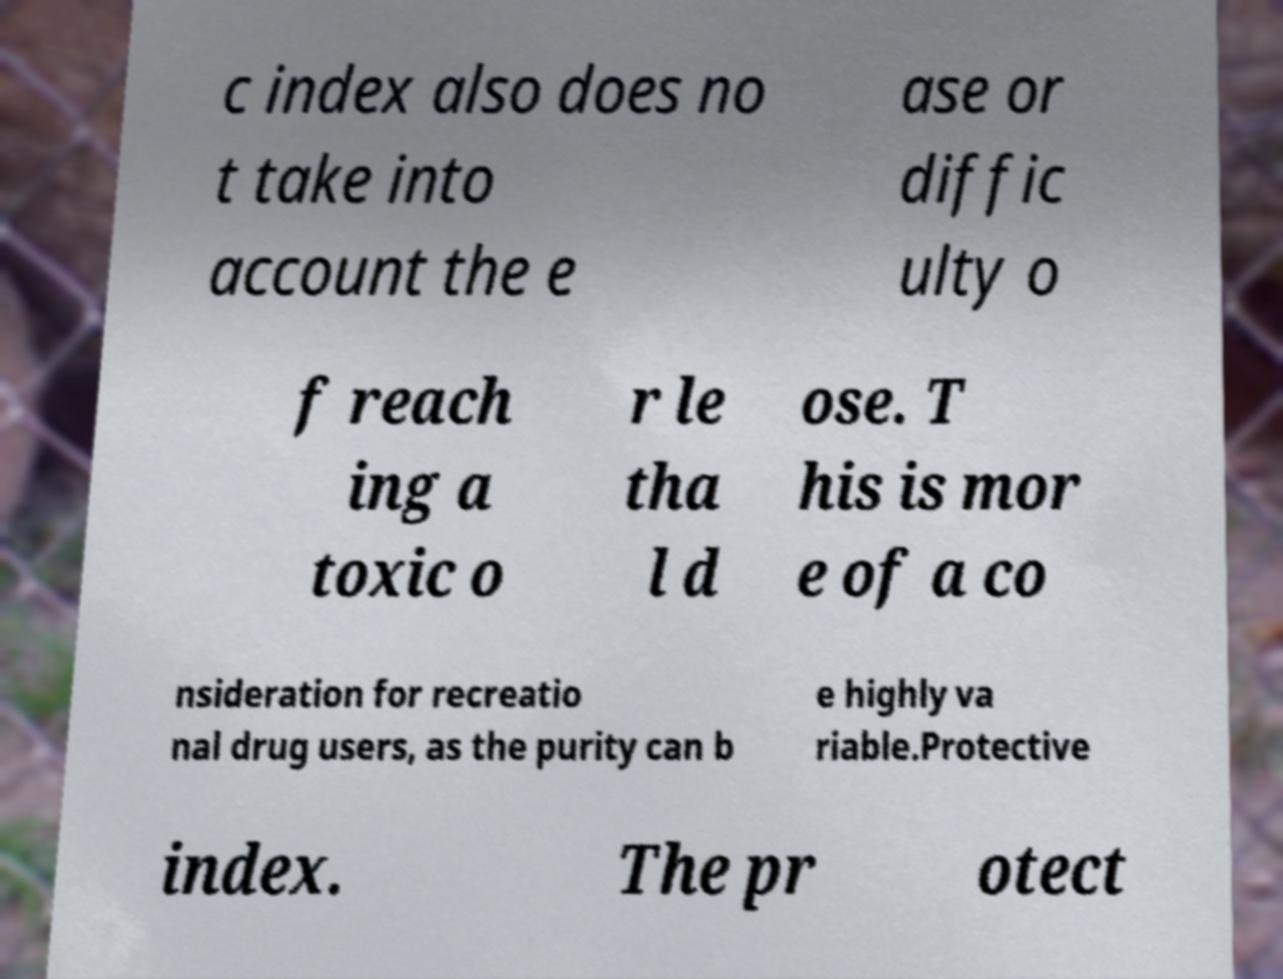I need the written content from this picture converted into text. Can you do that? c index also does no t take into account the e ase or diffic ulty o f reach ing a toxic o r le tha l d ose. T his is mor e of a co nsideration for recreatio nal drug users, as the purity can b e highly va riable.Protective index. The pr otect 